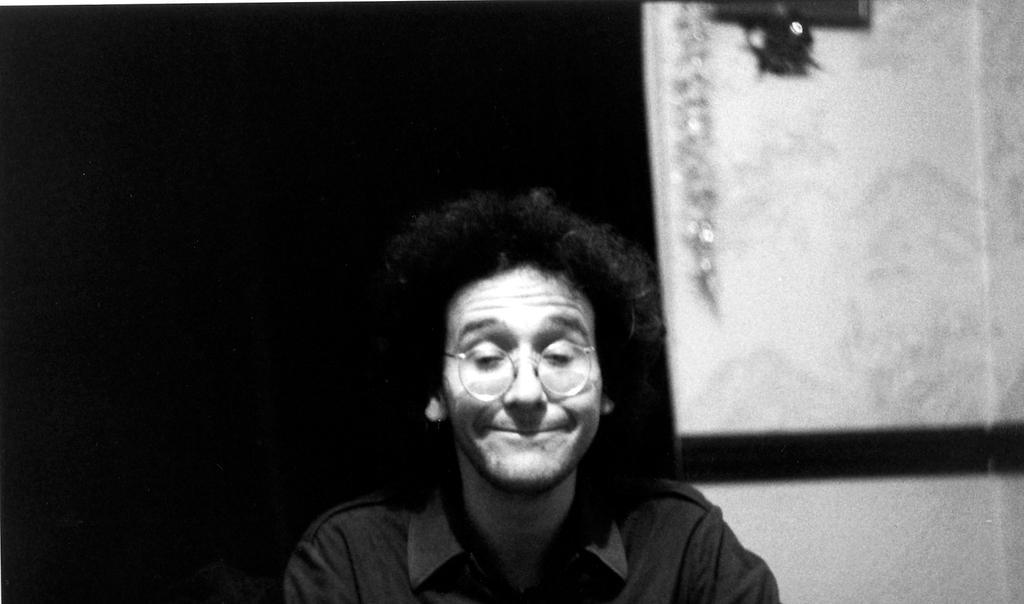How would you summarize this image in a sentence or two? This is a black and white image. In this image there is a person. 